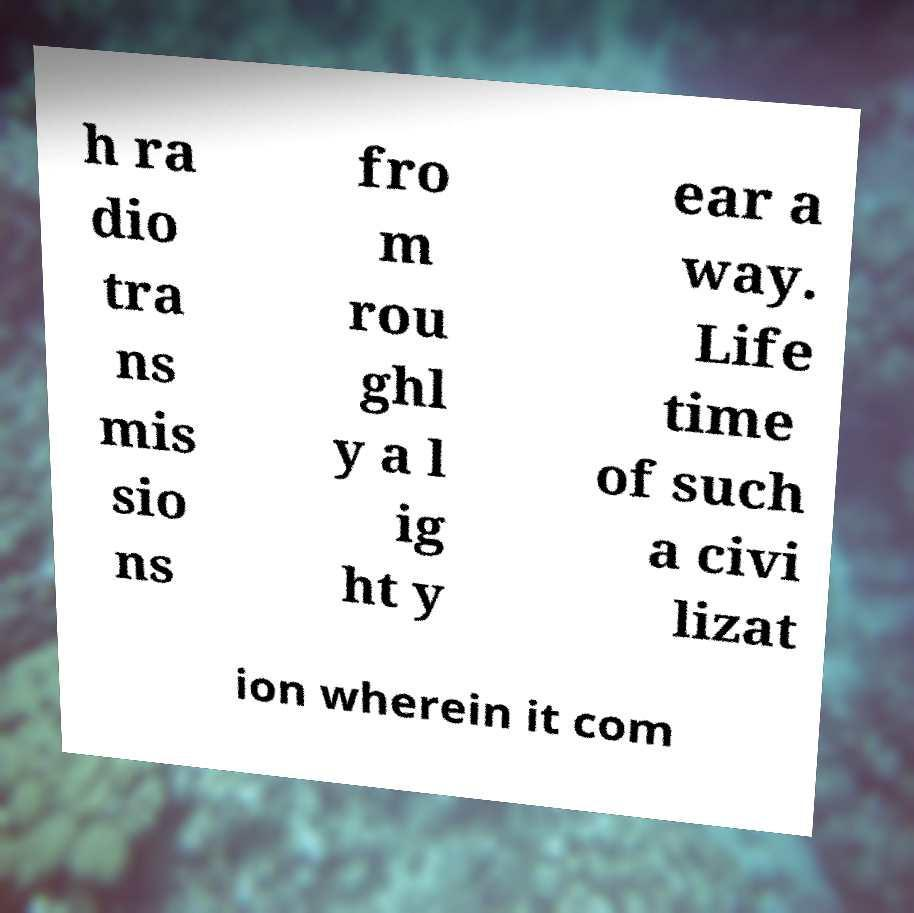Can you read and provide the text displayed in the image?This photo seems to have some interesting text. Can you extract and type it out for me? h ra dio tra ns mis sio ns fro m rou ghl y a l ig ht y ear a way. Life time of such a civi lizat ion wherein it com 